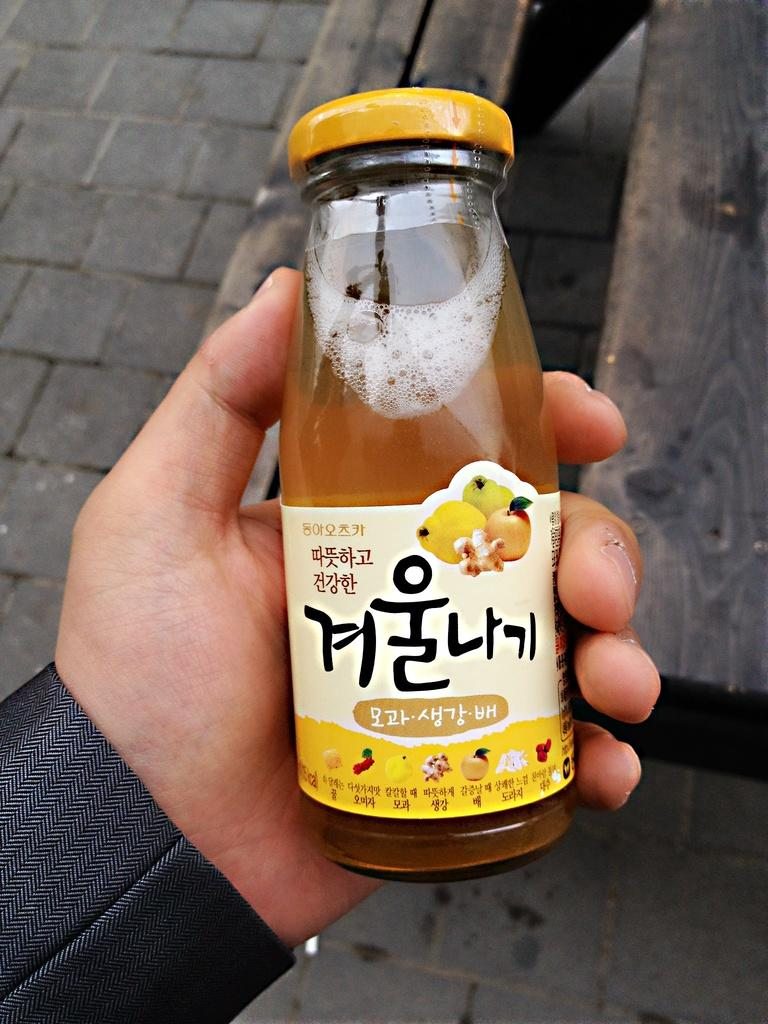What type of container is visible in the image? There is a small glass bottle in the image. What color is the closed lid of the bottle? The closed lid of the bottle has a yellow color. What might be inside the bottle based on its appearance? The bottle appears to be a juice bottle. Who is holding the bottle in the image? A person is holding the bottle in their hand. What type of zebra can be seen ringing the bells in the image? There is no zebra or bells present in the image; it only features a small glass bottle with a yellow lid. 